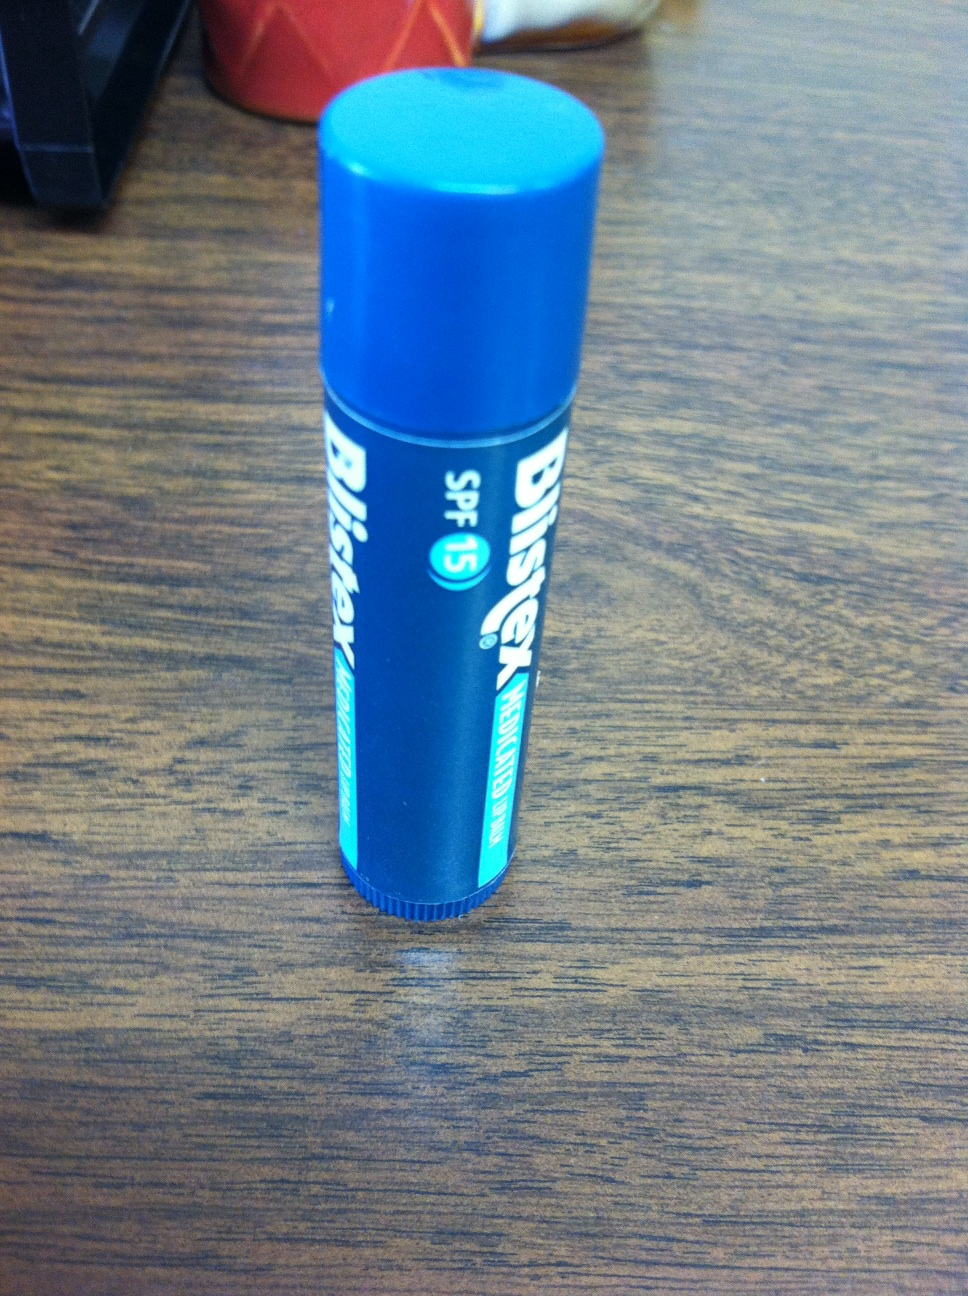Is there sunscreen in this chapstick? Yes, this chapstick contains sunscreen. The SPF (Sun Protection Factor) label indicates that it provides protection against the sun's harmful ultraviolet rays. In this case, the chapstick has SPF 15, which means it's designed to prevent sunburn and protect your lips from sun damage. 